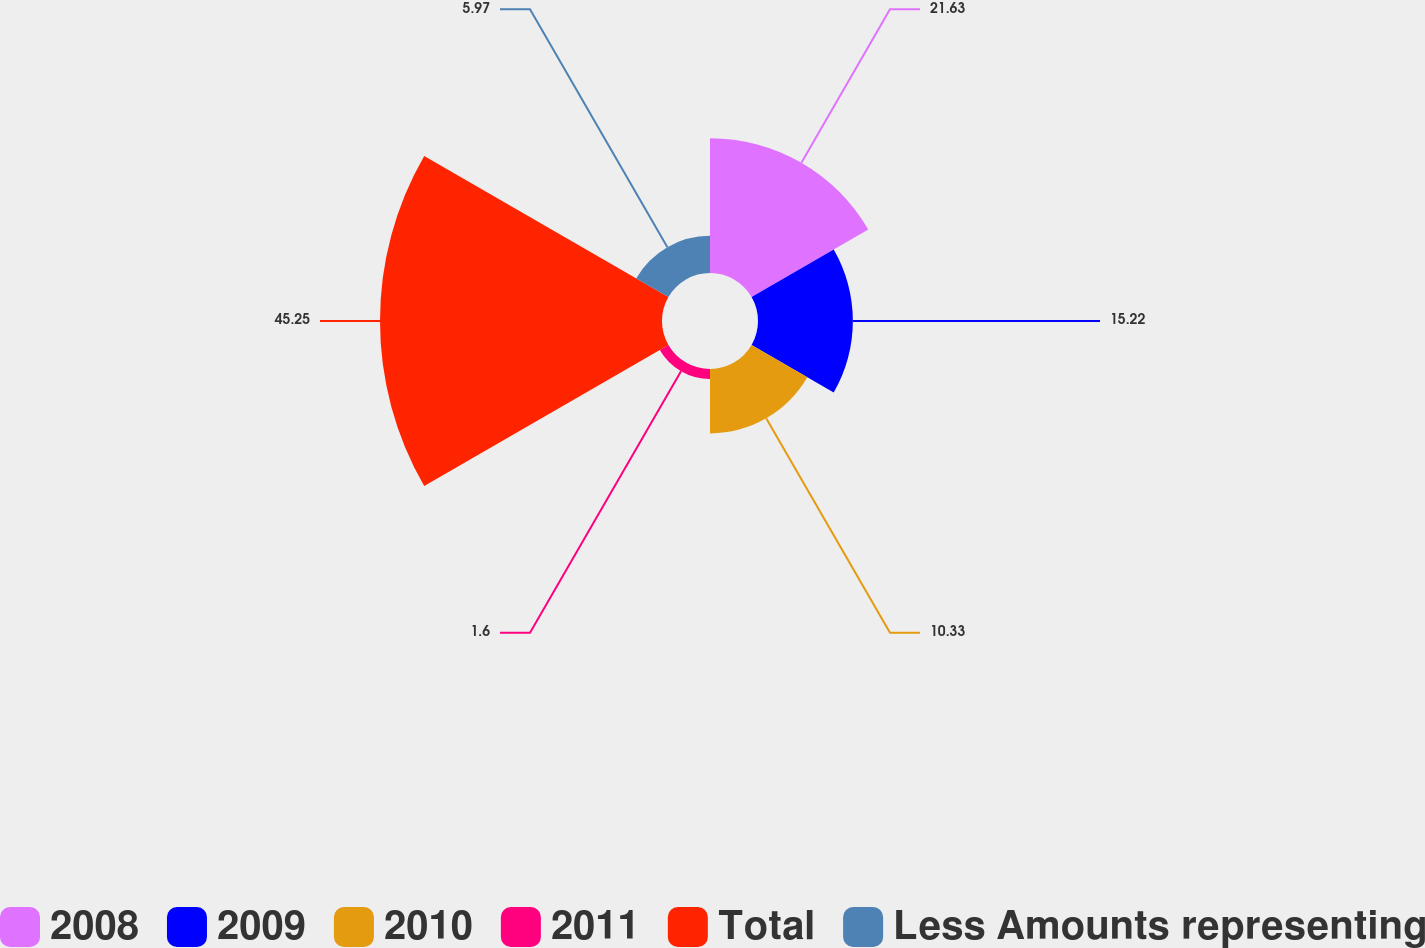<chart> <loc_0><loc_0><loc_500><loc_500><pie_chart><fcel>2008<fcel>2009<fcel>2010<fcel>2011<fcel>Total<fcel>Less Amounts representing<nl><fcel>21.63%<fcel>15.22%<fcel>10.33%<fcel>1.6%<fcel>45.25%<fcel>5.97%<nl></chart> 